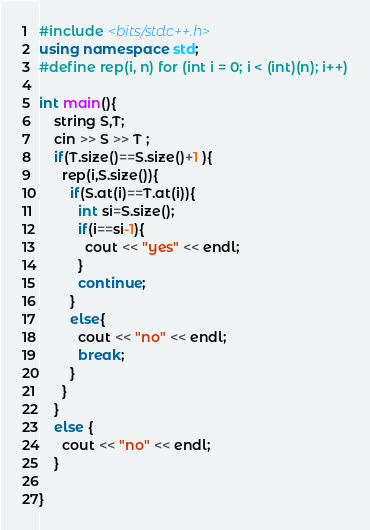<code> <loc_0><loc_0><loc_500><loc_500><_C++_>#include <bits/stdc++.h>
using namespace std;
#define rep(i, n) for (int i = 0; i < (int)(n); i++)

int main(){
	string S,T;
    cin >> S >> T ;
    if(T.size()==S.size()+1 ){
      rep(i,S.size()){
        if(S.at(i)==T.at(i)){
          int si=S.size();
          if(i==si-1){
            cout << "yes" << endl;
          }
          continue;
        }
        else{
          cout << "no" << endl;
          break;
        }
      }
    }
    else {
      cout << "no" << endl;
    }
     
}</code> 